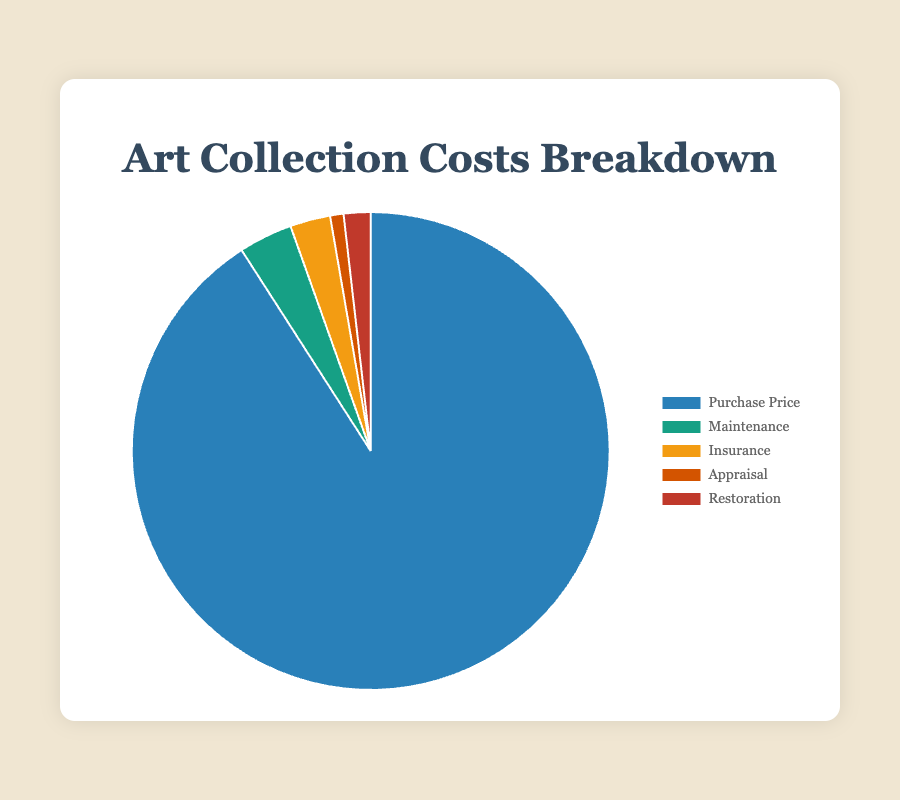What is the largest cost contributor in the art collection? By observing the pie chart, locate the largest segment. This segment represents the Purchase Price.
Answer: Purchase Price What is the combined cost of Maintenance and Insurance? Sum the amounts for Maintenance and Insurance: 200,000 + 150,000.
Answer: 350,000 Which cost is the smallest in the art collection? Observe the pie chart and identify the smallest segment, which corresponds to Appraisal.
Answer: Appraisal How does the cost of Restoration compare to Insurance? Compare the values directly, Restoration is 100,000 and Insurance is 150,000. Restoration is less expensive.
Answer: Restoration is less What percentage of the total cost is represented by Appraisal? Calculate (50,000 / (5,000,000 + 200,000 + 150,000 + 50,000 + 100,000)) * 100. The total cost is 5,500,000. The percentage is (50,000 / 5,500,000) * 100.
Answer: 0.91% What are the colors representing each cost in the pie chart? The chart uses specific colors for each segment: Purchase Price (blue), Maintenance (green), Insurance (yellow), Appraisal (orange), Restoration (red).
Answer: Purchase Price (blue), Maintenance (green), Insurance (yellow), Appraisal (orange), Restoration (red) By how much does the Purchase Price exceed the combined costs of Maintenance, Insurance, and Restoration? Sum the amounts of Maintenance, Insurance, and Restoration: 200,000 + 150,000 + 100,000 = 450,000. Then subtract this from Purchase Price: 5,000,000 - 450,000.
Answer: 4,550,000 Which two costs combined are closest to the cost of Maintenance? Add the pairs of the lower costs and find which sum is closest to 200,000: Appraisal + Restoration = 50,000 + 100,000 = 150,000.
Answer: Appraisal and Restoration What is the ratio of the Purchase Price to the total cost of the art collection? The total cost is 5,500,000 and the Purchase Price is 5,000,000. Calculate the ratio: 5,000,000 / 5,500,000.
Answer: approximately 0.91 